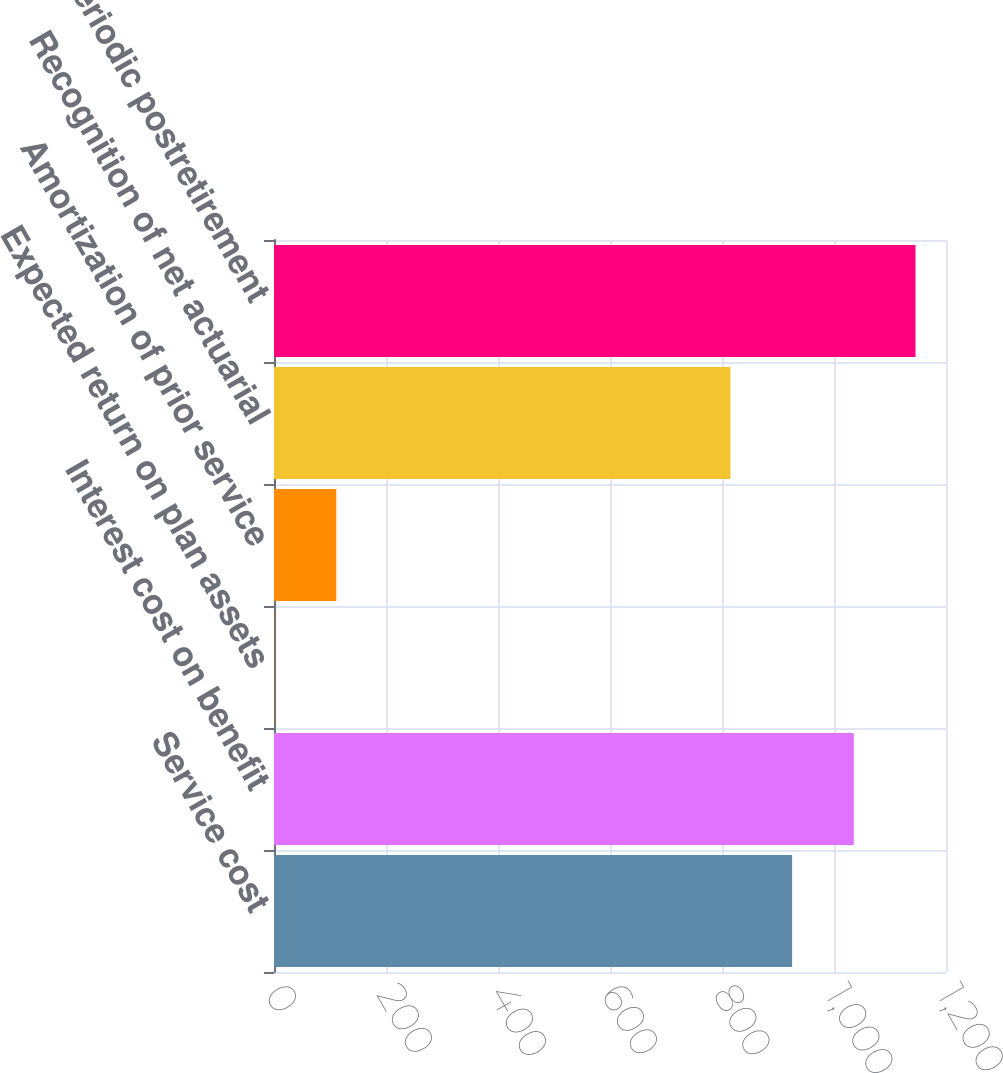Convert chart to OTSL. <chart><loc_0><loc_0><loc_500><loc_500><bar_chart><fcel>Service cost<fcel>Interest cost on benefit<fcel>Expected return on plan assets<fcel>Amortization of prior service<fcel>Recognition of net actuarial<fcel>Net periodic postretirement<nl><fcel>925.19<fcel>1035.38<fcel>1.07<fcel>111.26<fcel>815<fcel>1145.57<nl></chart> 